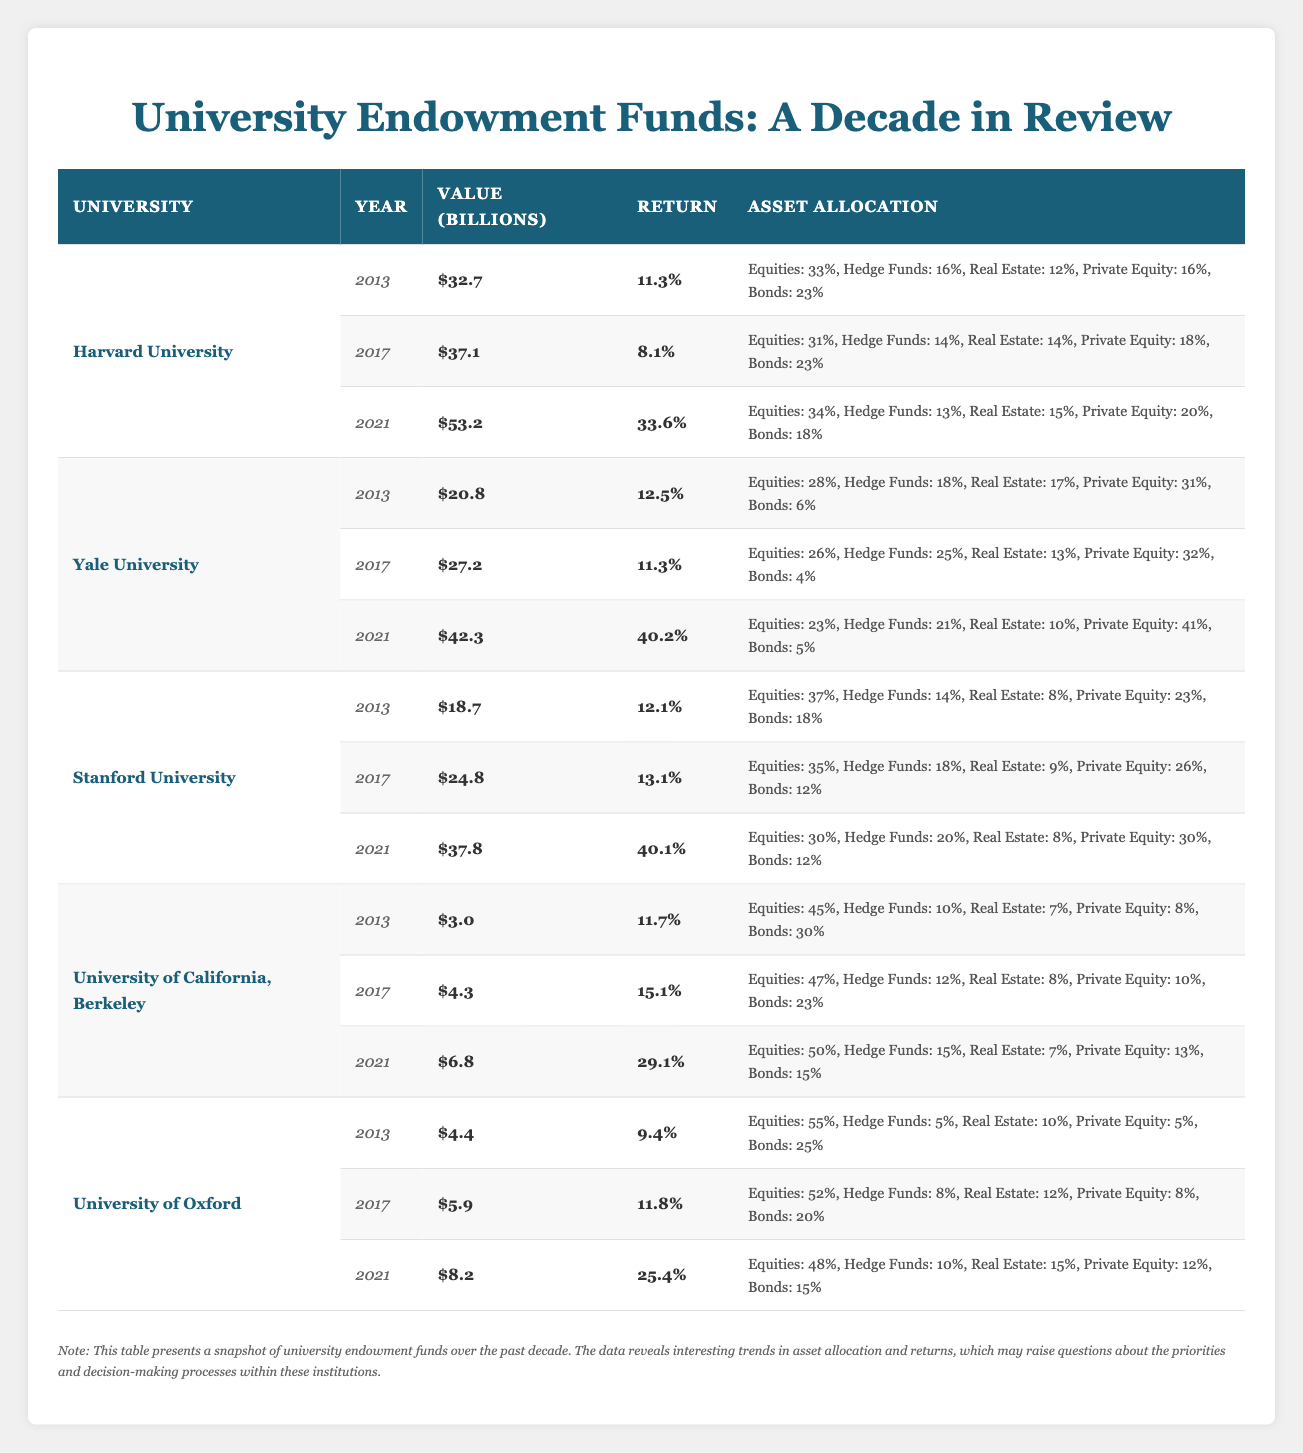What was the highest return achieved by Harvard University in the table? Reviewing the table, I see that Harvard University reported a return of 33.6% in the year 2021, which is the highest value listed for that university.
Answer: 33.6 Which university had the lowest endowment value in 2013? Looking at the endowment values for 2013, University of California, Berkeley had the lowest value at $3.0 billion.
Answer: 3.0 Is it true that Yale University had a higher average return than Harvard University over the years presented? To determine the averages, I calculate the returns for Yale: (12.5 + 11.3 + 40.2) / 3 = 21.67% and for Harvard: (11.3 + 8.1 + 33.6) / 3 = 17.67%. Since 21.67% is greater than 17.67%, the statement is true.
Answer: Yes What was the total return percentage for Stanford University across the years provided? Adding the returns for Stanford (12.1% + 13.1% + 40.1%), I get a total of 65.3%.
Answer: 65.3 Which university had the highest allocation in hedge funds in 2017? By examining the hedge fund allocations in 2017, Yale University had the highest allocation at 25%.
Answer: 25 What is the difference in endowment value for University of Oxford from 2013 to 2021? The endowment value for University of Oxford in 2021 is $8.2 billion, and in 2013, it was $4.4 billion. The difference is 8.2 - 4.4 = 3.8 billion.
Answer: 3.8 Did University of California, Berkeley increase its asset allocation in equities from 2013 to 2021? Checking the equity allocation, it increased from 45% in 2013 to 50% in 2021, indicating an increase.
Answer: Yes What was the average asset allocation for private equity across all universities in 2021? For 2021, the allocations for private equity are: Harvard (20%), Yale (41%), Stanford (30%), University of California, Berkeley (13%), University of Oxford (12%). Summing these gives 20 + 41 + 30 + 13 + 12 = 126, and dividing by 5 gives an average of 25.2%.
Answer: 25.2 